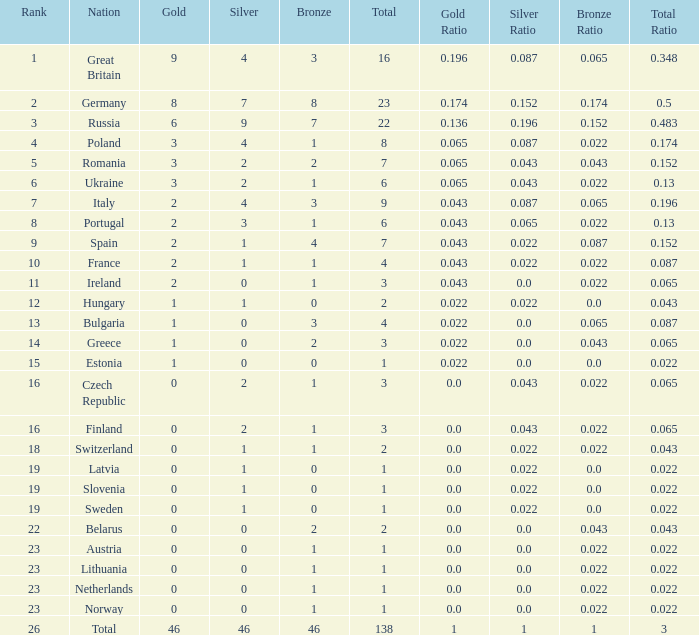What is the average rank when the bronze is larger than 1, and silver is less than 0? None. 